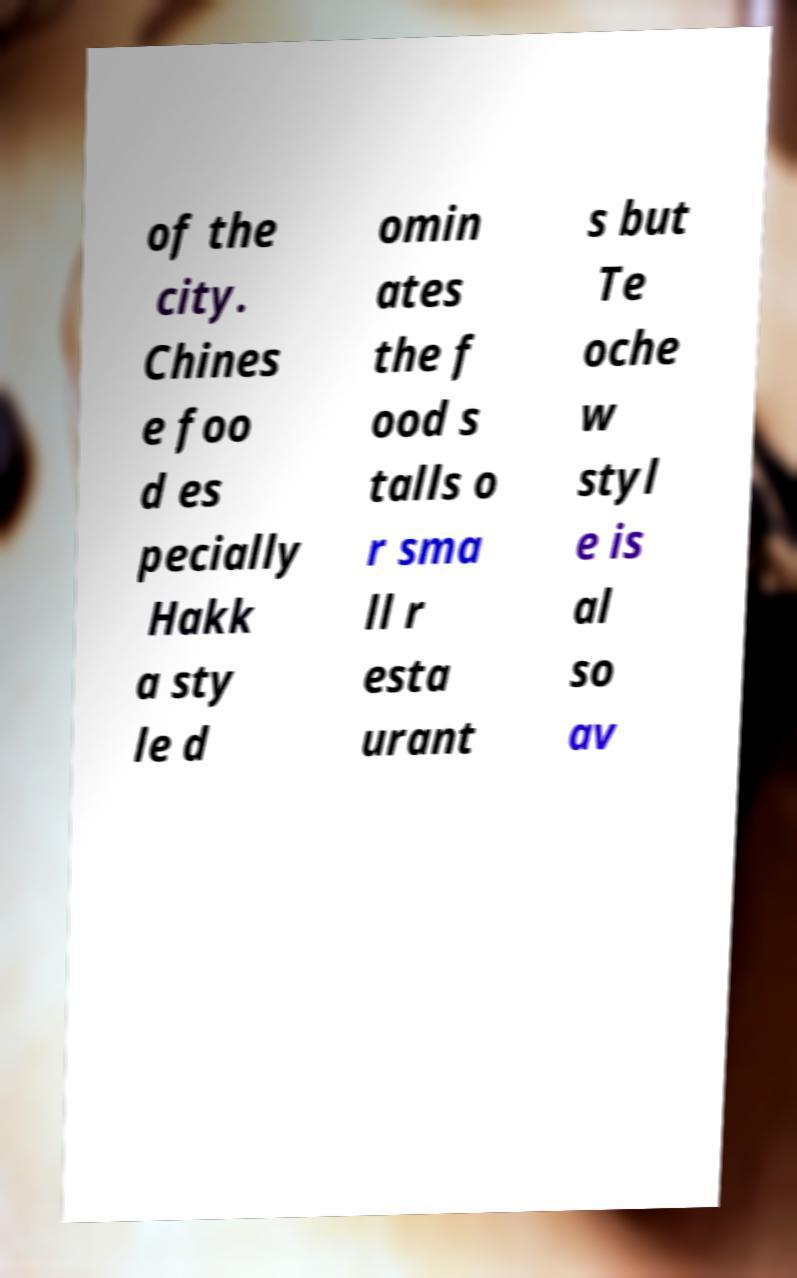What messages or text are displayed in this image? I need them in a readable, typed format. of the city. Chines e foo d es pecially Hakk a sty le d omin ates the f ood s talls o r sma ll r esta urant s but Te oche w styl e is al so av 